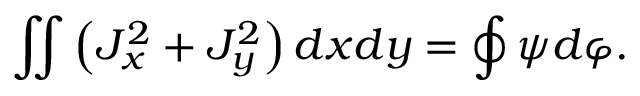Convert formula to latex. <formula><loc_0><loc_0><loc_500><loc_500>\iint \left ( J _ { x } ^ { 2 } + J _ { y } ^ { 2 } \right ) d x d y = \oint \psi d \varphi .</formula> 